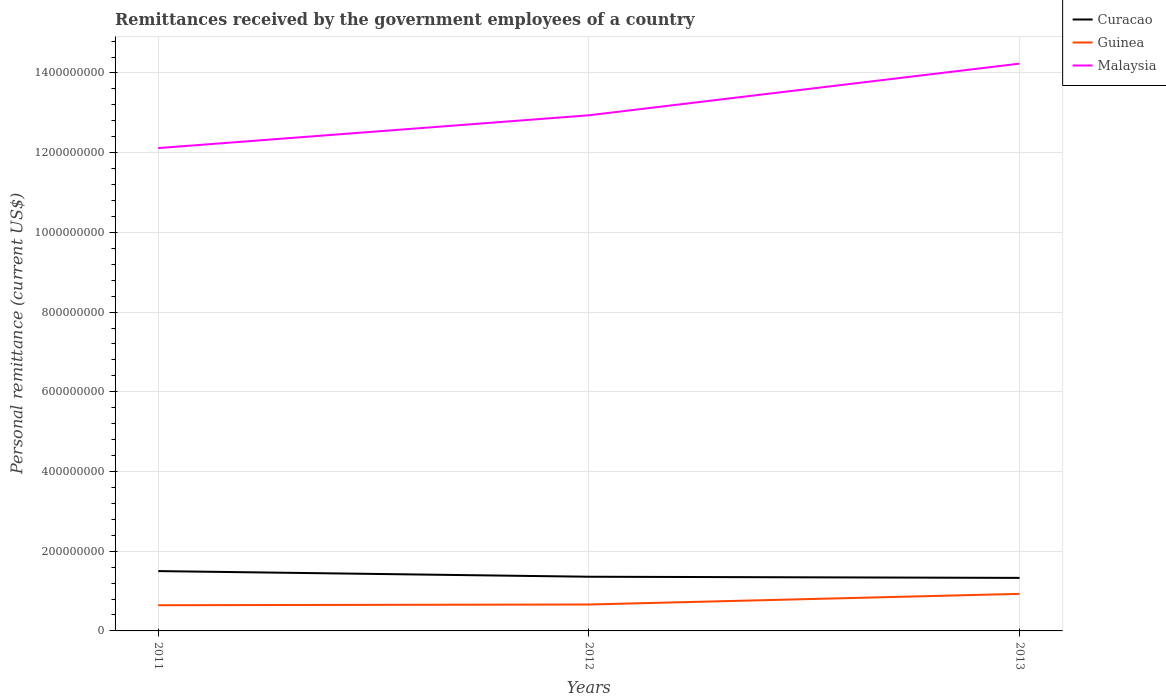How many different coloured lines are there?
Your response must be concise. 3. Across all years, what is the maximum remittances received by the government employees in Curacao?
Your response must be concise. 1.33e+08. In which year was the remittances received by the government employees in Curacao maximum?
Keep it short and to the point. 2013. What is the total remittances received by the government employees in Guinea in the graph?
Make the answer very short. -1.80e+06. What is the difference between the highest and the second highest remittances received by the government employees in Malaysia?
Keep it short and to the point. 2.12e+08. Does the graph contain any zero values?
Keep it short and to the point. No. Where does the legend appear in the graph?
Ensure brevity in your answer.  Top right. How many legend labels are there?
Provide a succinct answer. 3. How are the legend labels stacked?
Ensure brevity in your answer.  Vertical. What is the title of the graph?
Make the answer very short. Remittances received by the government employees of a country. Does "Morocco" appear as one of the legend labels in the graph?
Provide a short and direct response. No. What is the label or title of the Y-axis?
Provide a succinct answer. Personal remittance (current US$). What is the Personal remittance (current US$) in Curacao in 2011?
Provide a short and direct response. 1.50e+08. What is the Personal remittance (current US$) in Guinea in 2011?
Provide a succinct answer. 6.45e+07. What is the Personal remittance (current US$) of Malaysia in 2011?
Offer a very short reply. 1.21e+09. What is the Personal remittance (current US$) in Curacao in 2012?
Provide a short and direct response. 1.36e+08. What is the Personal remittance (current US$) of Guinea in 2012?
Ensure brevity in your answer.  6.63e+07. What is the Personal remittance (current US$) in Malaysia in 2012?
Keep it short and to the point. 1.29e+09. What is the Personal remittance (current US$) in Curacao in 2013?
Offer a very short reply. 1.33e+08. What is the Personal remittance (current US$) in Guinea in 2013?
Keep it short and to the point. 9.30e+07. What is the Personal remittance (current US$) of Malaysia in 2013?
Provide a short and direct response. 1.42e+09. Across all years, what is the maximum Personal remittance (current US$) of Curacao?
Your response must be concise. 1.50e+08. Across all years, what is the maximum Personal remittance (current US$) in Guinea?
Your response must be concise. 9.30e+07. Across all years, what is the maximum Personal remittance (current US$) in Malaysia?
Provide a succinct answer. 1.42e+09. Across all years, what is the minimum Personal remittance (current US$) in Curacao?
Keep it short and to the point. 1.33e+08. Across all years, what is the minimum Personal remittance (current US$) of Guinea?
Your answer should be compact. 6.45e+07. Across all years, what is the minimum Personal remittance (current US$) in Malaysia?
Make the answer very short. 1.21e+09. What is the total Personal remittance (current US$) of Curacao in the graph?
Offer a terse response. 4.19e+08. What is the total Personal remittance (current US$) of Guinea in the graph?
Offer a very short reply. 2.24e+08. What is the total Personal remittance (current US$) in Malaysia in the graph?
Keep it short and to the point. 3.93e+09. What is the difference between the Personal remittance (current US$) in Curacao in 2011 and that in 2012?
Offer a terse response. 1.42e+07. What is the difference between the Personal remittance (current US$) in Guinea in 2011 and that in 2012?
Your answer should be compact. -1.80e+06. What is the difference between the Personal remittance (current US$) in Malaysia in 2011 and that in 2012?
Offer a terse response. -8.23e+07. What is the difference between the Personal remittance (current US$) in Curacao in 2011 and that in 2013?
Provide a succinct answer. 1.71e+07. What is the difference between the Personal remittance (current US$) in Guinea in 2011 and that in 2013?
Give a very brief answer. -2.85e+07. What is the difference between the Personal remittance (current US$) of Malaysia in 2011 and that in 2013?
Ensure brevity in your answer.  -2.12e+08. What is the difference between the Personal remittance (current US$) in Curacao in 2012 and that in 2013?
Provide a succinct answer. 2.91e+06. What is the difference between the Personal remittance (current US$) of Guinea in 2012 and that in 2013?
Give a very brief answer. -2.67e+07. What is the difference between the Personal remittance (current US$) in Malaysia in 2012 and that in 2013?
Provide a short and direct response. -1.30e+08. What is the difference between the Personal remittance (current US$) in Curacao in 2011 and the Personal remittance (current US$) in Guinea in 2012?
Your response must be concise. 8.38e+07. What is the difference between the Personal remittance (current US$) of Curacao in 2011 and the Personal remittance (current US$) of Malaysia in 2012?
Your answer should be compact. -1.14e+09. What is the difference between the Personal remittance (current US$) of Guinea in 2011 and the Personal remittance (current US$) of Malaysia in 2012?
Your response must be concise. -1.23e+09. What is the difference between the Personal remittance (current US$) in Curacao in 2011 and the Personal remittance (current US$) in Guinea in 2013?
Make the answer very short. 5.71e+07. What is the difference between the Personal remittance (current US$) in Curacao in 2011 and the Personal remittance (current US$) in Malaysia in 2013?
Ensure brevity in your answer.  -1.27e+09. What is the difference between the Personal remittance (current US$) of Guinea in 2011 and the Personal remittance (current US$) of Malaysia in 2013?
Your response must be concise. -1.36e+09. What is the difference between the Personal remittance (current US$) of Curacao in 2012 and the Personal remittance (current US$) of Guinea in 2013?
Ensure brevity in your answer.  4.30e+07. What is the difference between the Personal remittance (current US$) of Curacao in 2012 and the Personal remittance (current US$) of Malaysia in 2013?
Your response must be concise. -1.29e+09. What is the difference between the Personal remittance (current US$) of Guinea in 2012 and the Personal remittance (current US$) of Malaysia in 2013?
Your answer should be very brief. -1.36e+09. What is the average Personal remittance (current US$) in Curacao per year?
Provide a succinct answer. 1.40e+08. What is the average Personal remittance (current US$) of Guinea per year?
Provide a succinct answer. 7.46e+07. What is the average Personal remittance (current US$) in Malaysia per year?
Make the answer very short. 1.31e+09. In the year 2011, what is the difference between the Personal remittance (current US$) of Curacao and Personal remittance (current US$) of Guinea?
Offer a very short reply. 8.56e+07. In the year 2011, what is the difference between the Personal remittance (current US$) in Curacao and Personal remittance (current US$) in Malaysia?
Your answer should be compact. -1.06e+09. In the year 2011, what is the difference between the Personal remittance (current US$) of Guinea and Personal remittance (current US$) of Malaysia?
Offer a very short reply. -1.15e+09. In the year 2012, what is the difference between the Personal remittance (current US$) of Curacao and Personal remittance (current US$) of Guinea?
Offer a very short reply. 6.97e+07. In the year 2012, what is the difference between the Personal remittance (current US$) in Curacao and Personal remittance (current US$) in Malaysia?
Ensure brevity in your answer.  -1.16e+09. In the year 2012, what is the difference between the Personal remittance (current US$) of Guinea and Personal remittance (current US$) of Malaysia?
Your answer should be very brief. -1.23e+09. In the year 2013, what is the difference between the Personal remittance (current US$) of Curacao and Personal remittance (current US$) of Guinea?
Ensure brevity in your answer.  4.00e+07. In the year 2013, what is the difference between the Personal remittance (current US$) in Curacao and Personal remittance (current US$) in Malaysia?
Keep it short and to the point. -1.29e+09. In the year 2013, what is the difference between the Personal remittance (current US$) of Guinea and Personal remittance (current US$) of Malaysia?
Your response must be concise. -1.33e+09. What is the ratio of the Personal remittance (current US$) of Curacao in 2011 to that in 2012?
Provide a short and direct response. 1.1. What is the ratio of the Personal remittance (current US$) in Guinea in 2011 to that in 2012?
Make the answer very short. 0.97. What is the ratio of the Personal remittance (current US$) of Malaysia in 2011 to that in 2012?
Make the answer very short. 0.94. What is the ratio of the Personal remittance (current US$) of Curacao in 2011 to that in 2013?
Ensure brevity in your answer.  1.13. What is the ratio of the Personal remittance (current US$) of Guinea in 2011 to that in 2013?
Ensure brevity in your answer.  0.69. What is the ratio of the Personal remittance (current US$) in Malaysia in 2011 to that in 2013?
Provide a succinct answer. 0.85. What is the ratio of the Personal remittance (current US$) in Curacao in 2012 to that in 2013?
Provide a succinct answer. 1.02. What is the ratio of the Personal remittance (current US$) of Guinea in 2012 to that in 2013?
Your answer should be compact. 0.71. What is the ratio of the Personal remittance (current US$) in Malaysia in 2012 to that in 2013?
Ensure brevity in your answer.  0.91. What is the difference between the highest and the second highest Personal remittance (current US$) in Curacao?
Your answer should be very brief. 1.42e+07. What is the difference between the highest and the second highest Personal remittance (current US$) of Guinea?
Your answer should be very brief. 2.67e+07. What is the difference between the highest and the second highest Personal remittance (current US$) in Malaysia?
Keep it short and to the point. 1.30e+08. What is the difference between the highest and the lowest Personal remittance (current US$) of Curacao?
Offer a very short reply. 1.71e+07. What is the difference between the highest and the lowest Personal remittance (current US$) in Guinea?
Your answer should be compact. 2.85e+07. What is the difference between the highest and the lowest Personal remittance (current US$) of Malaysia?
Your response must be concise. 2.12e+08. 